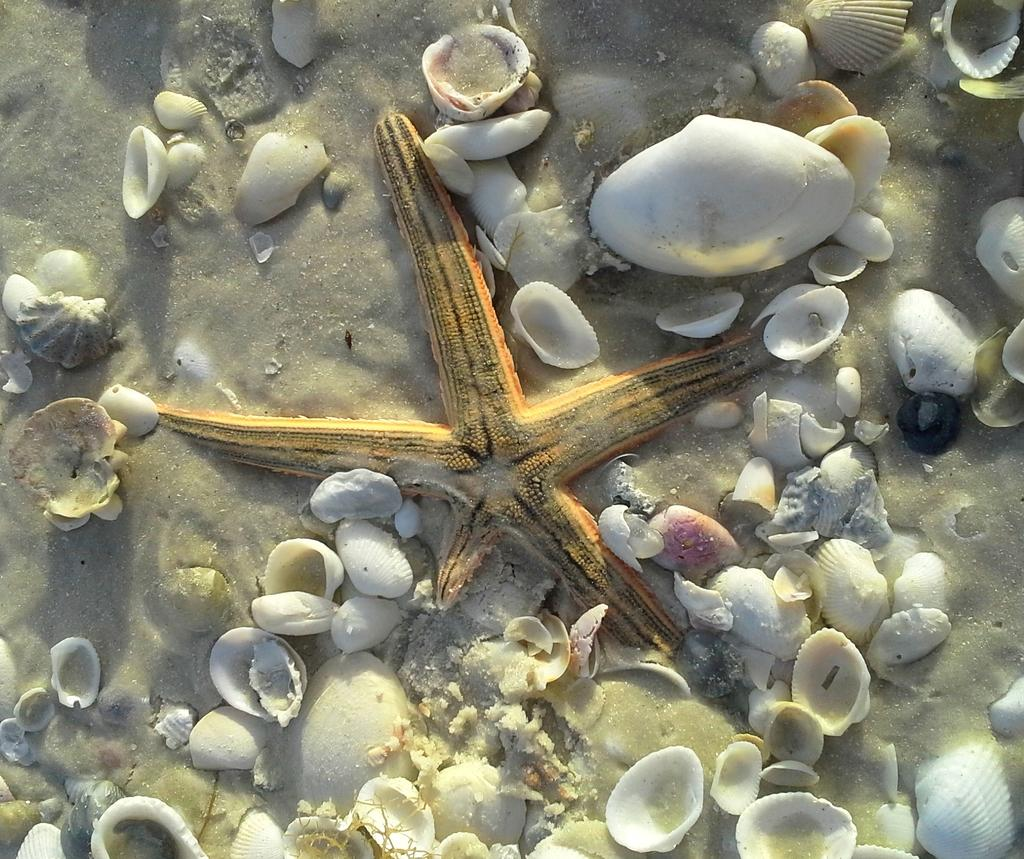What type of sea creature is in the image? There is a starfish in the image. What color is the starfish? The starfish is yellow. What else can be seen on the ground in the image? There are white shells on the ground in the image. How do the shells vary in the image? The shells come in different sizes. Where is the turkey located in the image? There is no turkey present in the image. What type of lace can be seen on the starfish in the image? There is no lace present on the starfish in the image. 